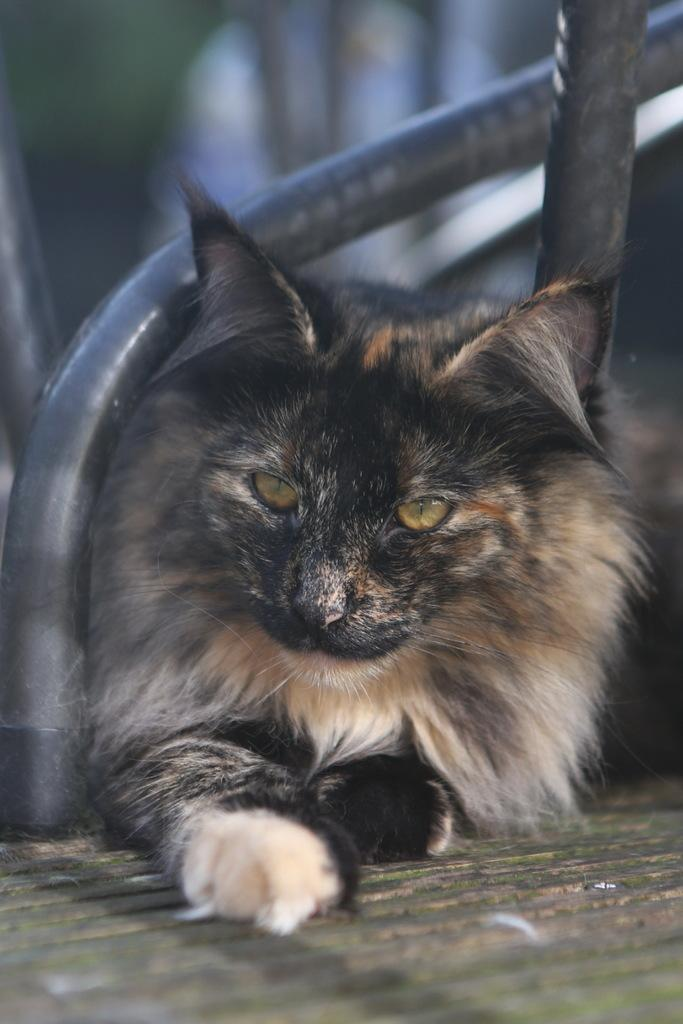What type of animal can be seen in the image? There is a cat in the image. What objects are present in the image besides the cat? There are poles in the image. What can be seen beneath the cat and poles in the image? The ground is visible in the image. How would you describe the background of the image? The background of the image is blurred. What type of cord is hanging from the cat's neck in the image? There is no cord hanging from the cat's neck in the image; the cat is not wearing any accessories. 